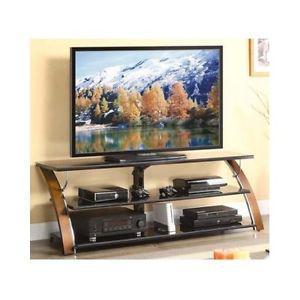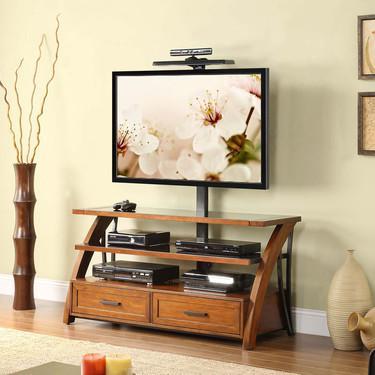The first image is the image on the left, the second image is the image on the right. Assess this claim about the two images: "There is a dark brown wall behind the television in both images.". Correct or not? Answer yes or no. No. The first image is the image on the left, the second image is the image on the right. For the images shown, is this caption "Left and right images each feature a TV stand with a curved piece on each end, but do not have the same picture playing on the TV." true? Answer yes or no. Yes. 